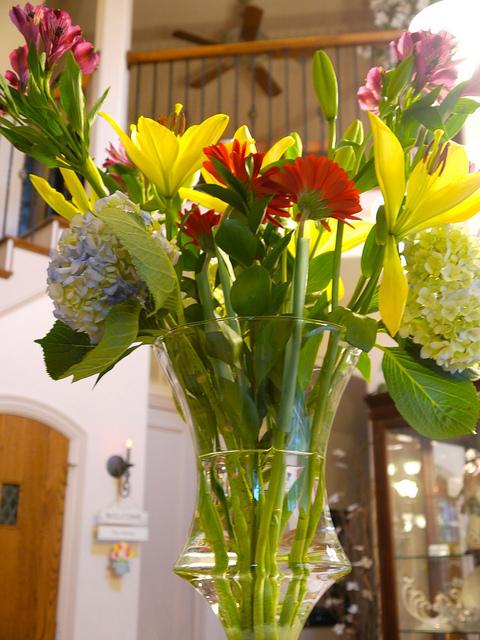What color are the tallest flowers?
Concise answer only. Purple. What kind of fan?
Write a very short answer. Ceiling. What is in the vase?
Concise answer only. Flowers. 